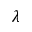<formula> <loc_0><loc_0><loc_500><loc_500>\lambda</formula> 